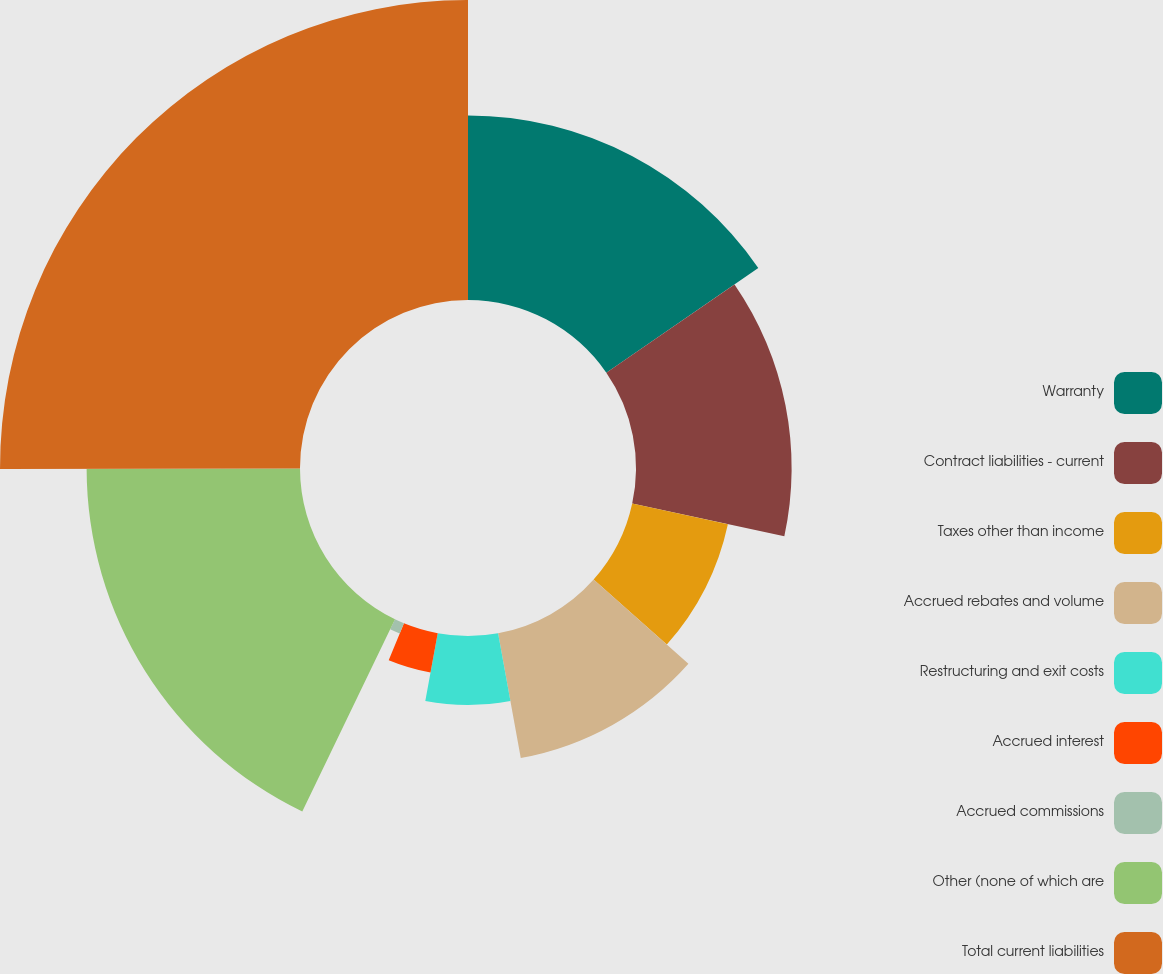Convert chart. <chart><loc_0><loc_0><loc_500><loc_500><pie_chart><fcel>Warranty<fcel>Contract liabilities - current<fcel>Taxes other than income<fcel>Accrued rebates and volume<fcel>Restructuring and exit costs<fcel>Accrued interest<fcel>Accrued commissions<fcel>Other (none of which are<fcel>Total current liabilities<nl><fcel>15.4%<fcel>12.99%<fcel>8.17%<fcel>10.58%<fcel>5.75%<fcel>3.34%<fcel>0.93%<fcel>17.81%<fcel>25.04%<nl></chart> 